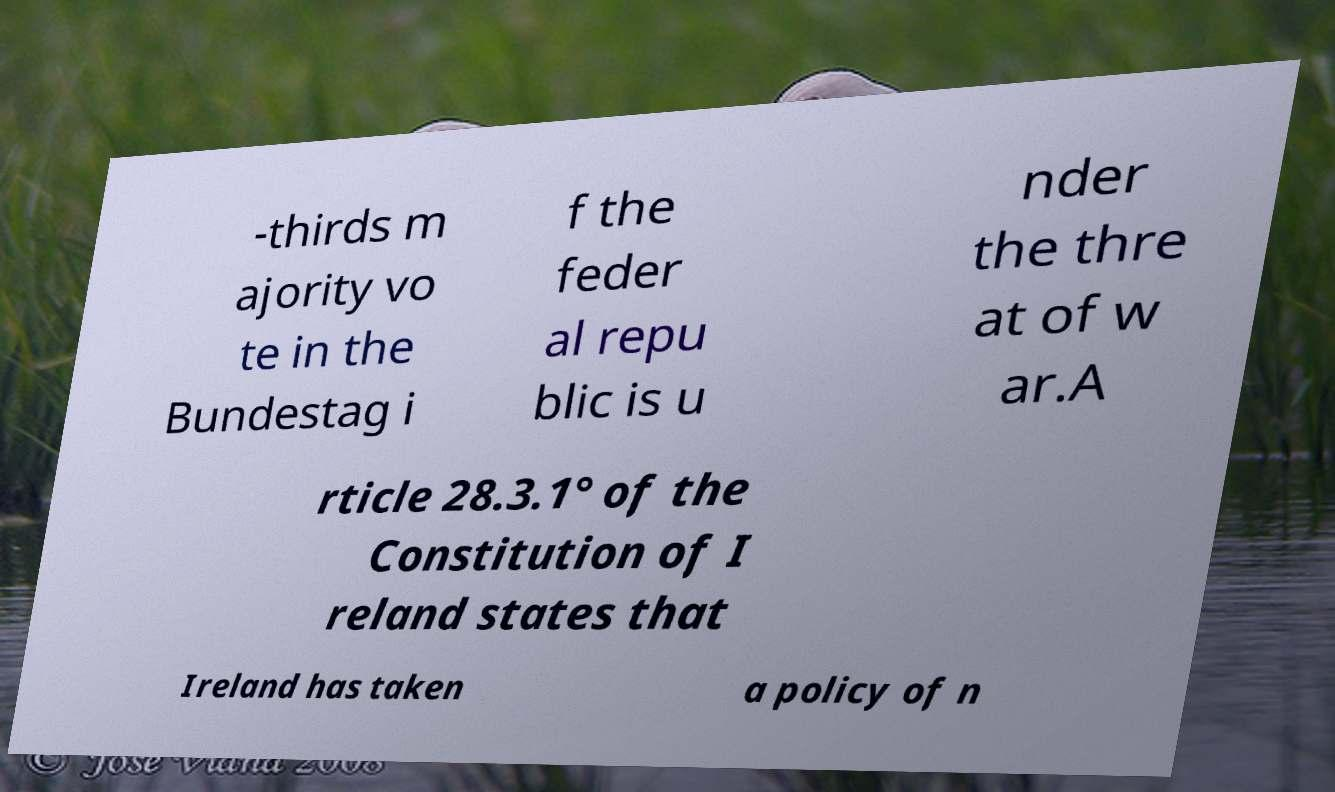Could you extract and type out the text from this image? -thirds m ajority vo te in the Bundestag i f the feder al repu blic is u nder the thre at of w ar.A rticle 28.3.1° of the Constitution of I reland states that Ireland has taken a policy of n 